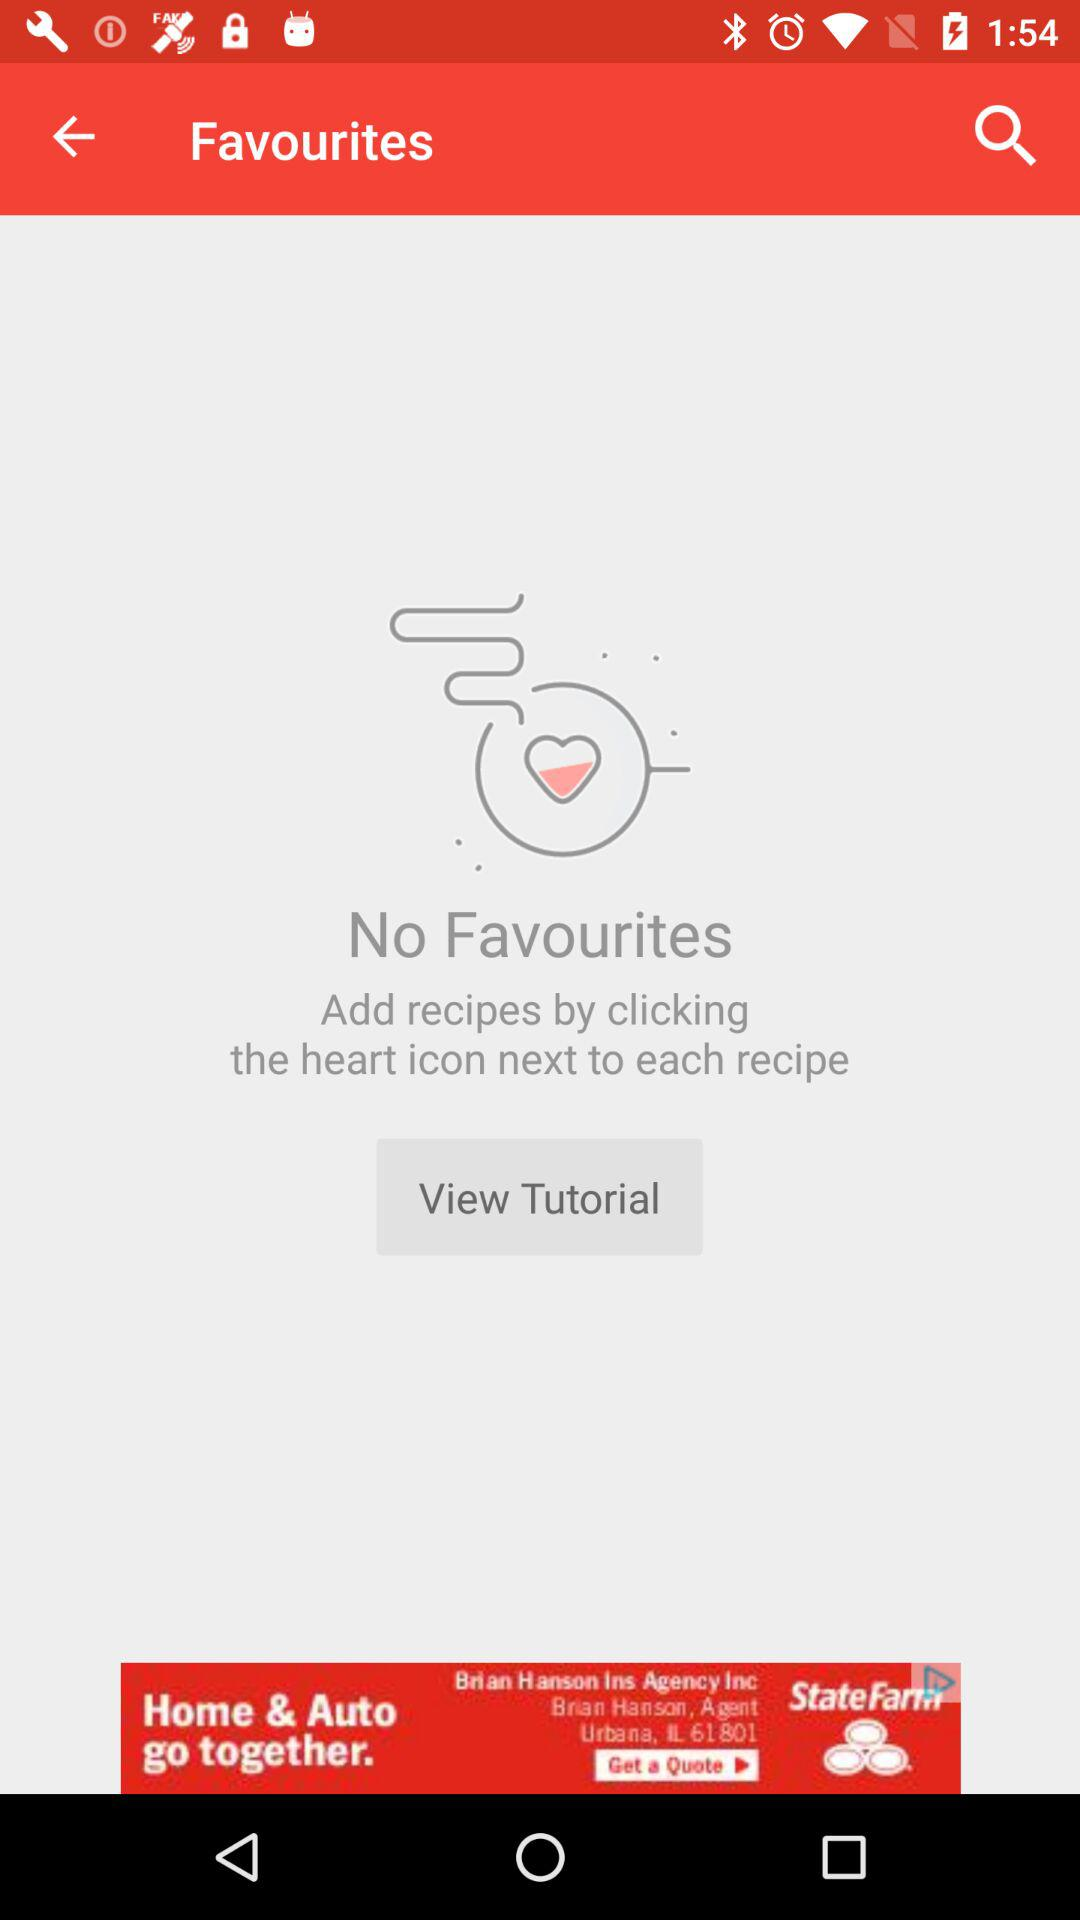How can new recipes be added? The new recipes can be added by clicking the heart icon next to each recipe. 